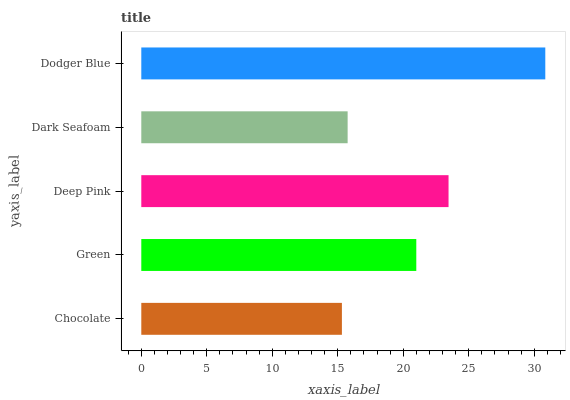Is Chocolate the minimum?
Answer yes or no. Yes. Is Dodger Blue the maximum?
Answer yes or no. Yes. Is Green the minimum?
Answer yes or no. No. Is Green the maximum?
Answer yes or no. No. Is Green greater than Chocolate?
Answer yes or no. Yes. Is Chocolate less than Green?
Answer yes or no. Yes. Is Chocolate greater than Green?
Answer yes or no. No. Is Green less than Chocolate?
Answer yes or no. No. Is Green the high median?
Answer yes or no. Yes. Is Green the low median?
Answer yes or no. Yes. Is Chocolate the high median?
Answer yes or no. No. Is Deep Pink the low median?
Answer yes or no. No. 